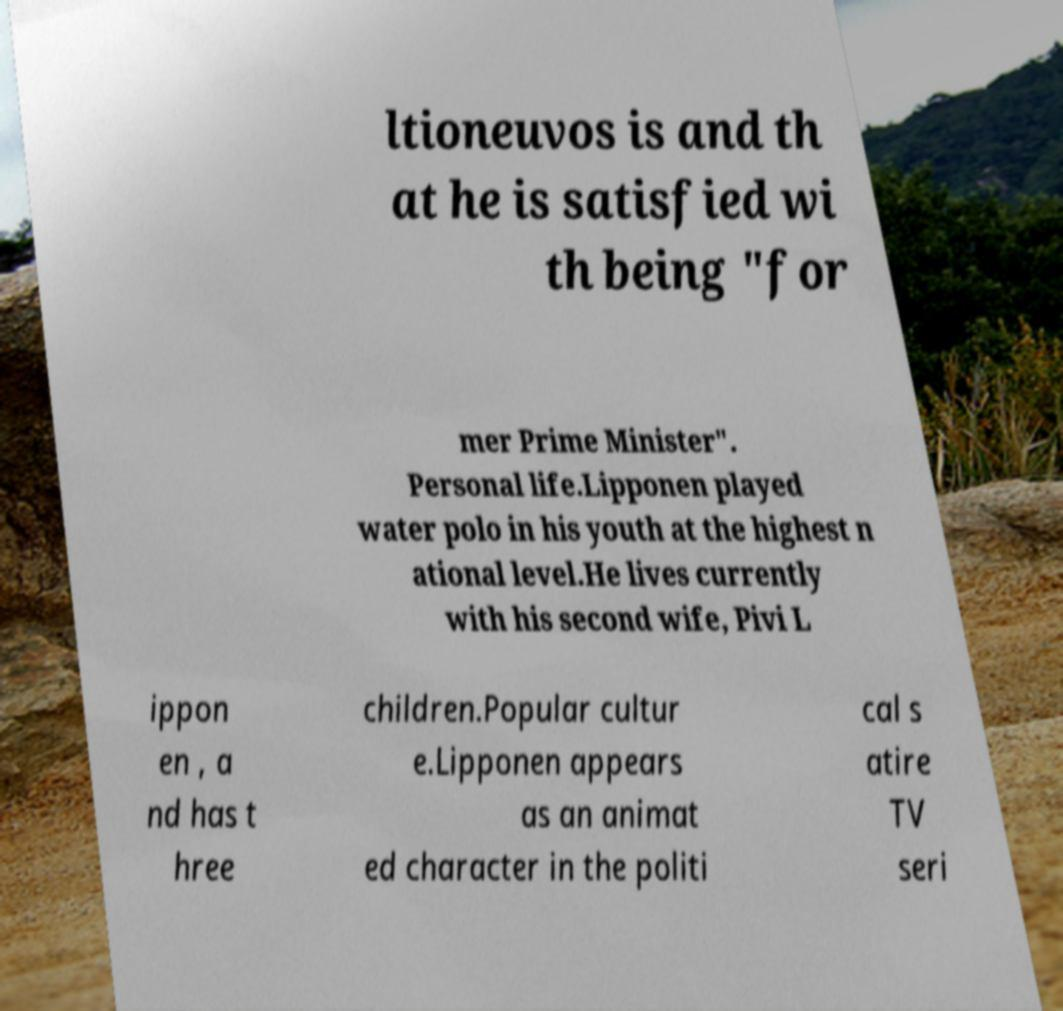Please read and relay the text visible in this image. What does it say? ltioneuvos is and th at he is satisfied wi th being "for mer Prime Minister". Personal life.Lipponen played water polo in his youth at the highest n ational level.He lives currently with his second wife, Pivi L ippon en , a nd has t hree children.Popular cultur e.Lipponen appears as an animat ed character in the politi cal s atire TV seri 